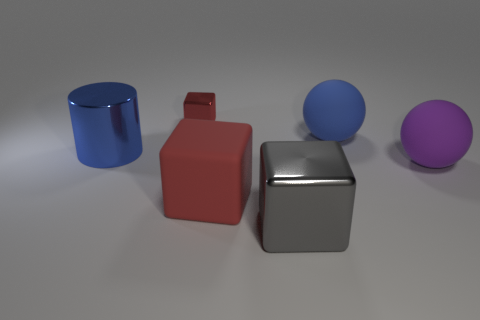Add 3 small purple cylinders. How many objects exist? 9 Subtract all balls. How many objects are left? 4 Add 4 gray shiny blocks. How many gray shiny blocks exist? 5 Subtract 1 red blocks. How many objects are left? 5 Subtract all purple rubber cubes. Subtract all big gray things. How many objects are left? 5 Add 4 big gray metal blocks. How many big gray metal blocks are left? 5 